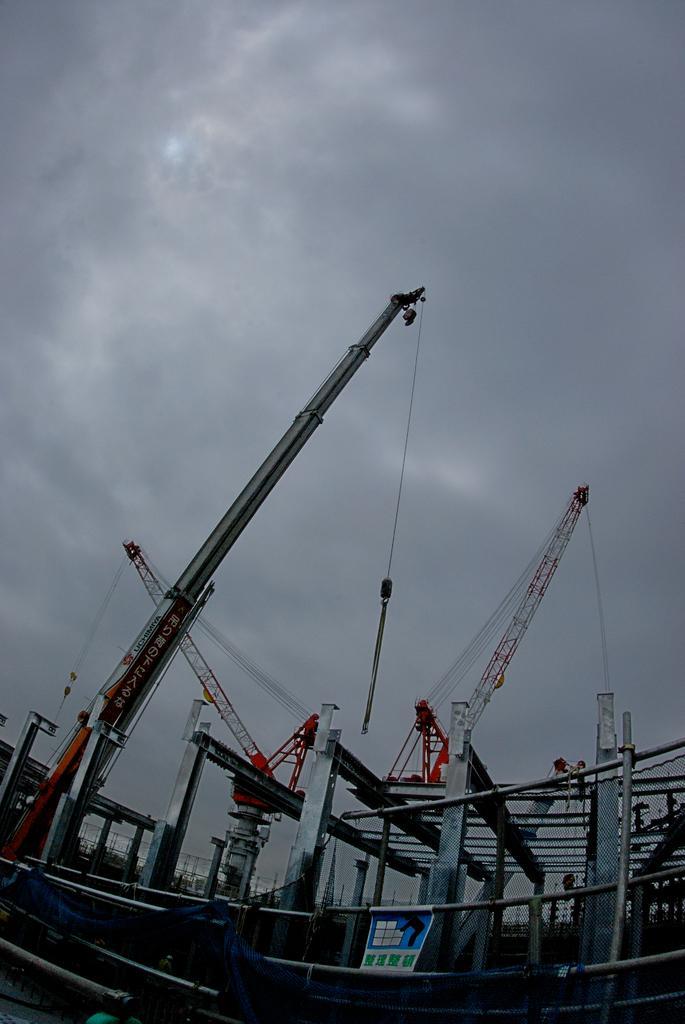In one or two sentences, can you explain what this image depicts? In this image there are cranes, rods and there is a poster on the rod. In the background of the image there is sky. 